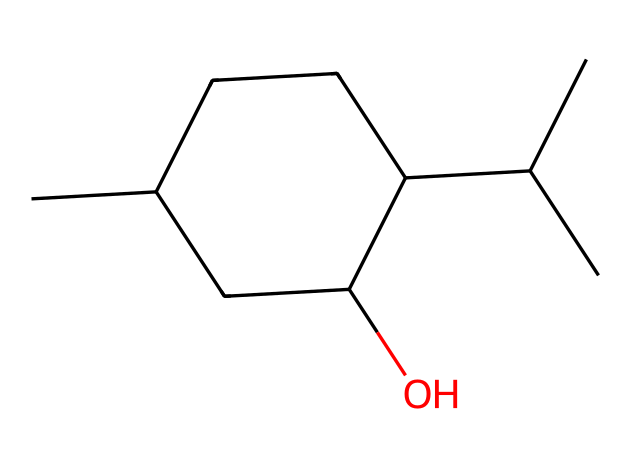How many carbon atoms are in menthol? The SMILES representation indicates there are five 'C' symbols in the main chain and additional two 'C' symbols as branches, totaling seven carbon atoms.
Answer: seven What is the functional group present in menthol? The 'O' in the SMILES indicates an alcohol functional group, as it signifies the presence of a hydroxyl (-OH) group associated with one of the carbon atoms.
Answer: alcohol What is the total number of hydrogen atoms in menthol? For each carbon atom, there will generally be two or three associated hydrogen atoms, but the presence of the alcohol group and the structural branching means there are a total of 14 hydrogen atoms calculated from the structure.
Answer: fourteen Is menthol likely to dissolve in water? Menthol contains a hydroxyl group that usually enhances solubility in water, but due to its hydrocarbon structure and non-polar parts, it is primarily classified as a non-electrolyte.
Answer: yes Why is menthol classified as a non-electrolyte? Menthol does not dissociate into ions when dissolved in water because it does not possess ionic bonds; it remains largely intact as a molecular structure without forming charged particles.
Answer: non-electrolyte 